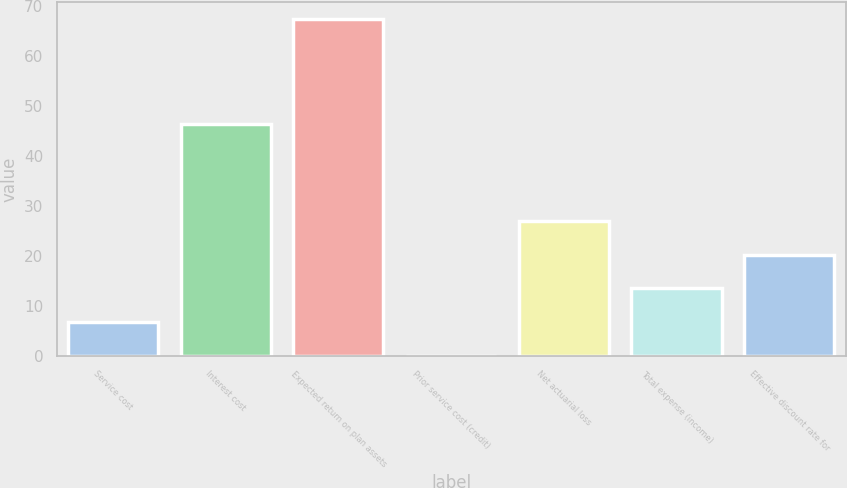<chart> <loc_0><loc_0><loc_500><loc_500><bar_chart><fcel>Service cost<fcel>Interest cost<fcel>Expected return on plan assets<fcel>Prior service cost (credit)<fcel>Net actuarial loss<fcel>Total expense (income)<fcel>Effective discount rate for<nl><fcel>6.84<fcel>46.4<fcel>67.5<fcel>0.1<fcel>27.06<fcel>13.58<fcel>20.32<nl></chart> 